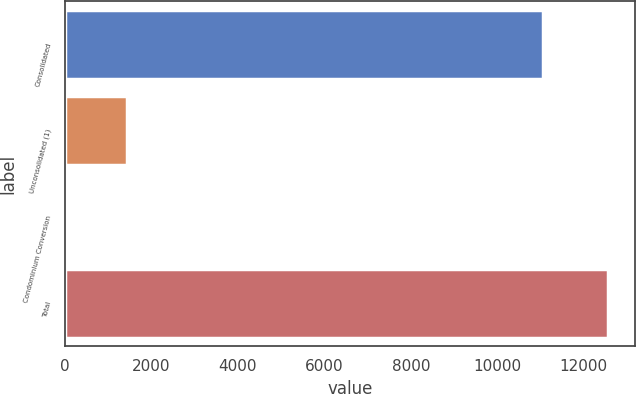Convert chart. <chart><loc_0><loc_0><loc_500><loc_500><bar_chart><fcel>Consolidated<fcel>Unconsolidated (1)<fcel>Condominium Conversion<fcel>Total<nl><fcel>11055<fcel>1434<fcel>62<fcel>12551<nl></chart> 